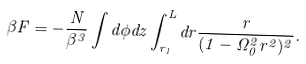Convert formula to latex. <formula><loc_0><loc_0><loc_500><loc_500>\beta F = - \frac { N } { \beta ^ { 3 } } \int d \phi d z \int _ { r _ { 1 } } ^ { L } d r \frac { r } { ( 1 - \Omega _ { 0 } ^ { 2 } r ^ { 2 } ) ^ { 2 } } .</formula> 